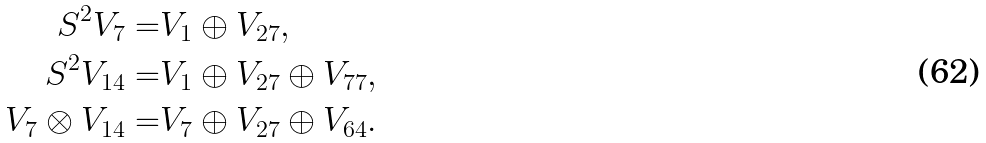Convert formula to latex. <formula><loc_0><loc_0><loc_500><loc_500>S ^ { 2 } V _ { 7 } = & V _ { 1 } \oplus V _ { 2 7 } , \\ S ^ { 2 } V _ { 1 4 } = & V _ { 1 } \oplus V _ { 2 7 } \oplus V _ { 7 7 } , \\ V _ { 7 } \otimes V _ { 1 4 } = & V _ { 7 } \oplus V _ { 2 7 } \oplus V _ { 6 4 } .</formula> 